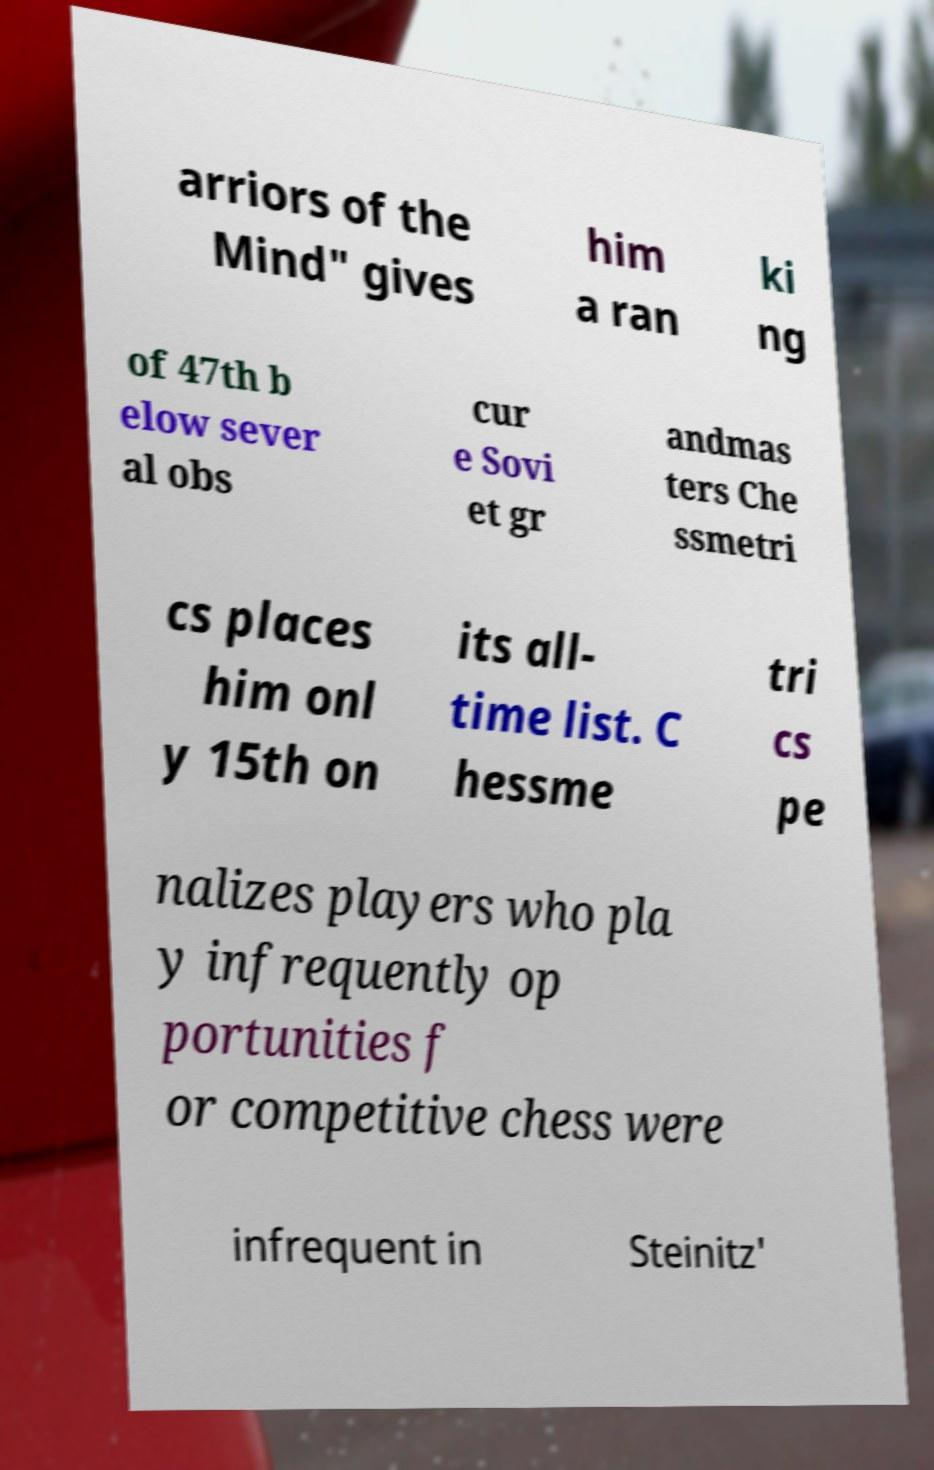Please read and relay the text visible in this image. What does it say? arriors of the Mind" gives him a ran ki ng of 47th b elow sever al obs cur e Sovi et gr andmas ters Che ssmetri cs places him onl y 15th on its all- time list. C hessme tri cs pe nalizes players who pla y infrequently op portunities f or competitive chess were infrequent in Steinitz' 